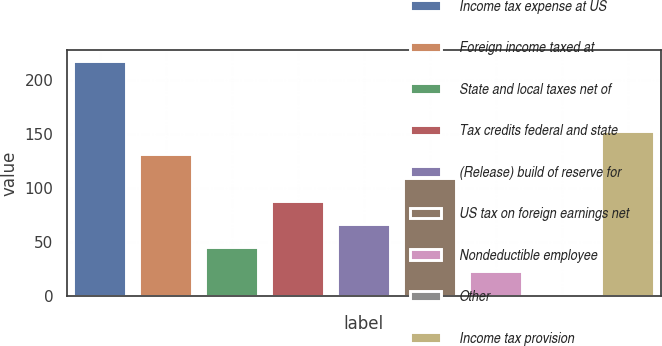Convert chart to OTSL. <chart><loc_0><loc_0><loc_500><loc_500><bar_chart><fcel>Income tax expense at US<fcel>Foreign income taxed at<fcel>State and local taxes net of<fcel>Tax credits federal and state<fcel>(Release) build of reserve for<fcel>US tax on foreign earnings net<fcel>Nondeductible employee<fcel>Other<fcel>Income tax provision<nl><fcel>217.8<fcel>131.48<fcel>45.16<fcel>88.32<fcel>66.74<fcel>109.9<fcel>23.58<fcel>2<fcel>153.06<nl></chart> 